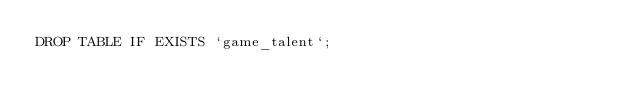Convert code to text. <code><loc_0><loc_0><loc_500><loc_500><_SQL_>DROP TABLE IF EXISTS `game_talent`;
</code> 